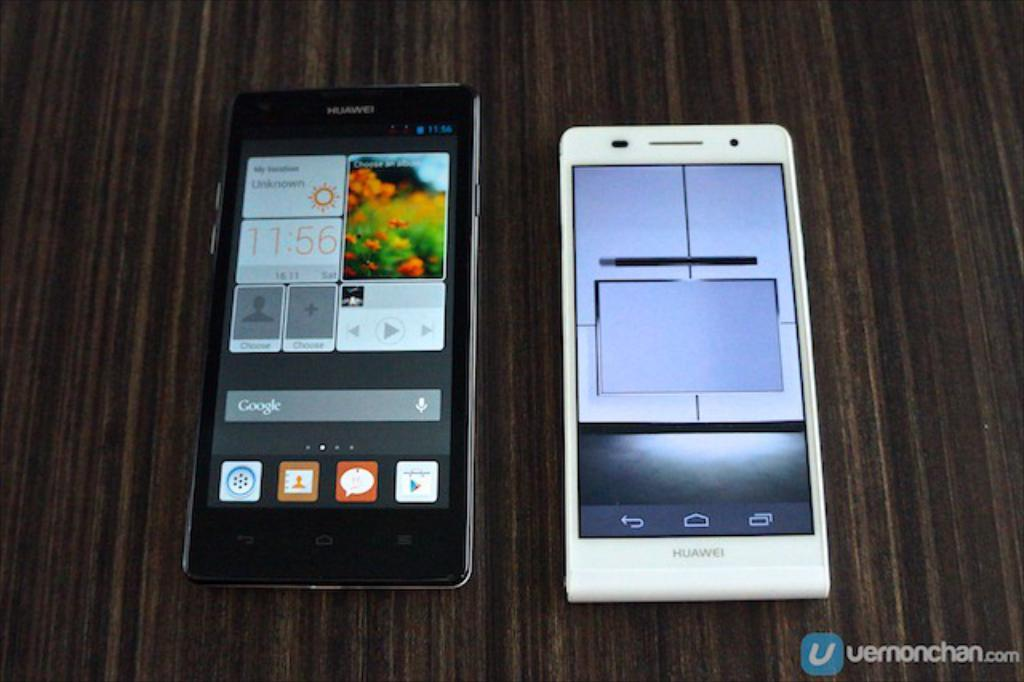What color is the mobile phone on the left side of the image? The mobile phone on the left side of the image is black. What color is the mobile phone on the right side of the image? The mobile phone on the right side of the image is white. Can you see any bees buzzing around the mobile phones in the image? There are no bees present in the image. Is there any blood visible on either of the mobile phones in the image? There is no blood visible on either of the mobile phones in the image. 